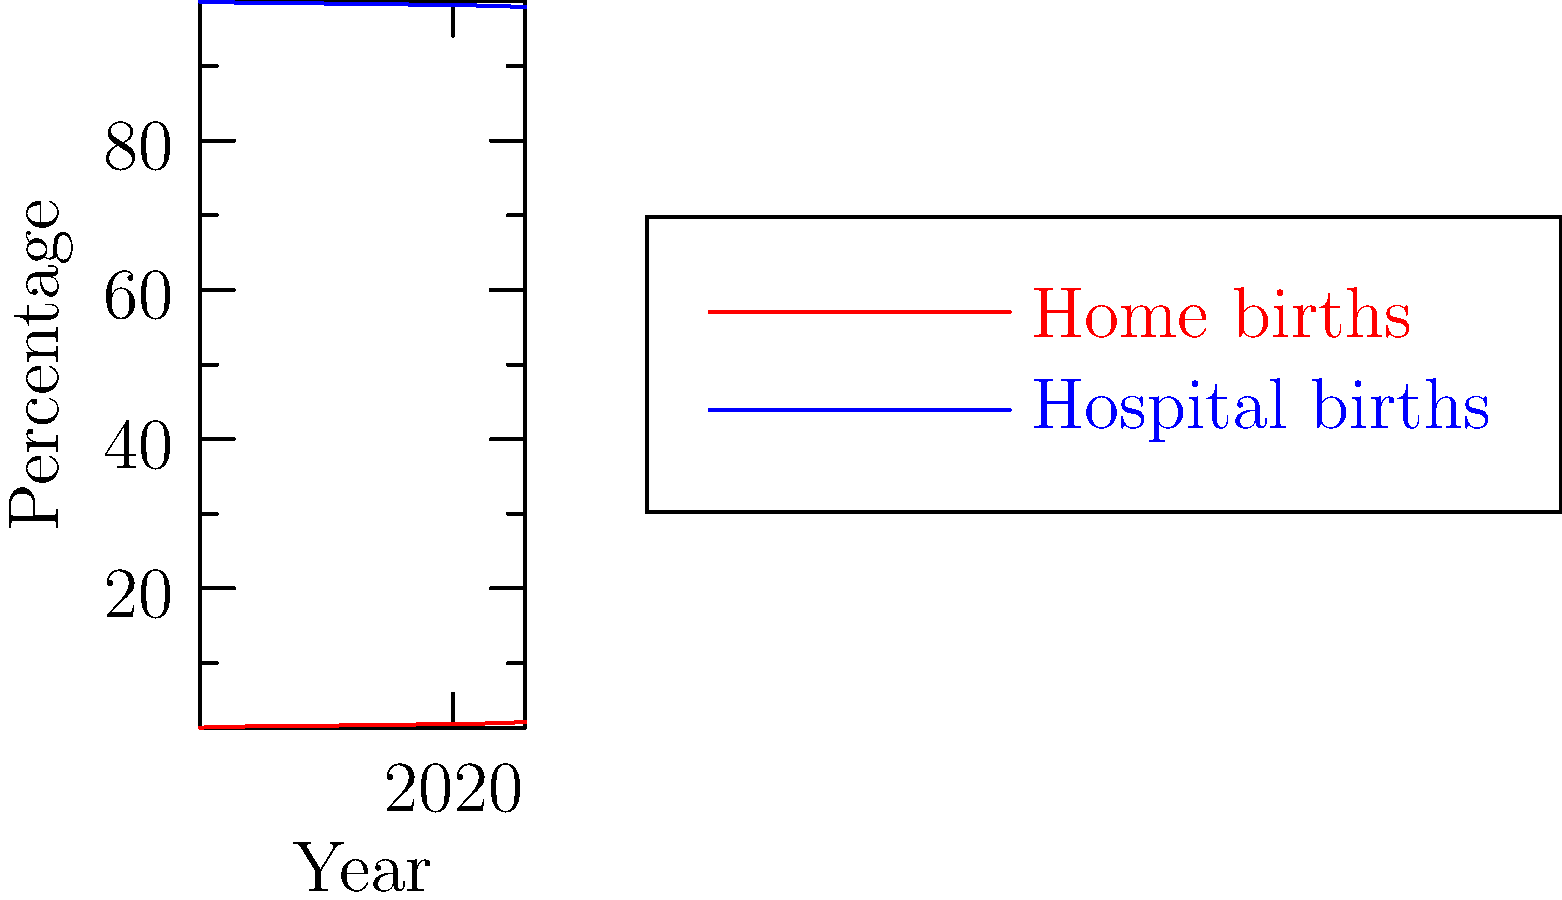Based on the line graph showing the trend of home births vs. hospital births over the past decade, what can be concluded about the rate of change in home births? To determine the rate of change in home births, we need to analyze the trend line for home births (red line) in the graph:

1. Observe the starting point: In 2013, home births were at 1.36%.
2. Observe the ending point: In 2022, home births reached 2.10%.
3. Calculate the total change: 2.10% - 1.36% = 0.74%
4. Calculate the time span: 2022 - 2013 = 9 years
5. Calculate the average rate of change: 0.74% / 9 years ≈ 0.082% per year

The line for home births shows a steady increase over the decade, with a relatively constant slope. This indicates a consistent upward trend.

Given the persona of "a strong advocate for natural birth," it's important to note that while the increase is steady, it's also gradual. The percentage of home births remains small compared to hospital births, but the trend is clearly moving in a direction that supports the growing interest in natural birth options.
Answer: Steady increase of approximately 0.082% per year 